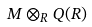<formula> <loc_0><loc_0><loc_500><loc_500>M \otimes _ { R } Q ( R )</formula> 